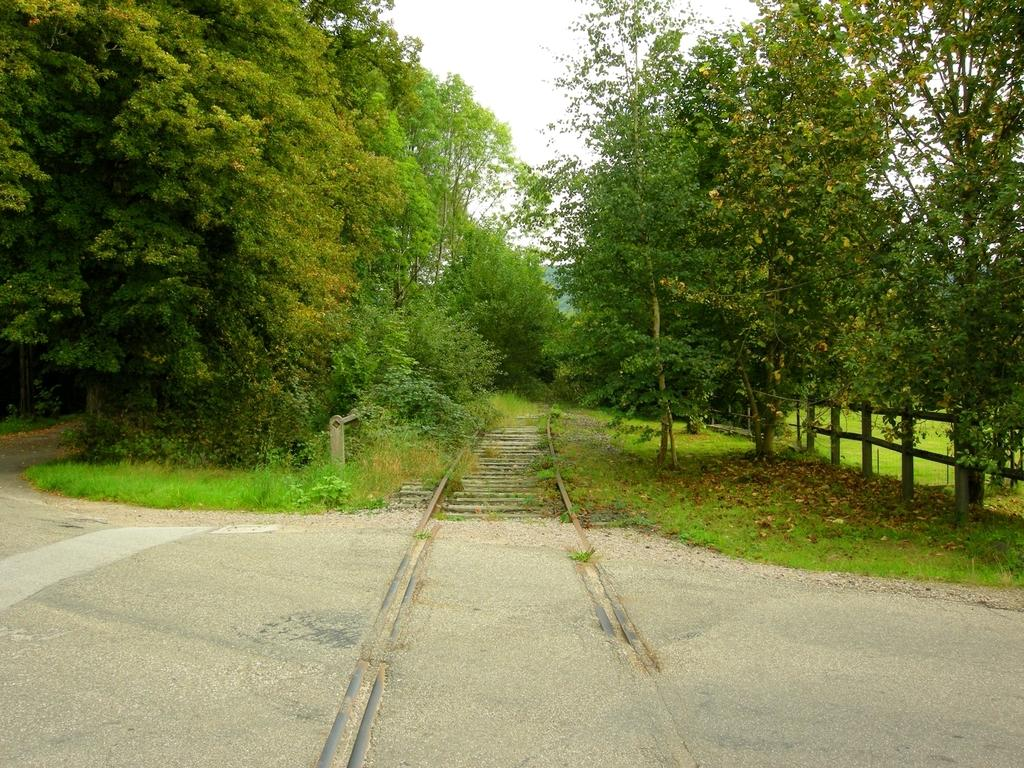What type of transportation infrastructure is present in the image? There is a railway track in the image. What other type of transportation infrastructure is present in the image? There is a road in the image. What can be seen in the middle of the image? There are green color trees in the middle of the image. What is visible at the top of the image? The sky is visible at the top of the image. What type of bell can be heard ringing in the image? There is no bell present in the image, and therefore no sound can be heard. What color are the pen and teeth in the image? There is no pen or teeth present in the image. 